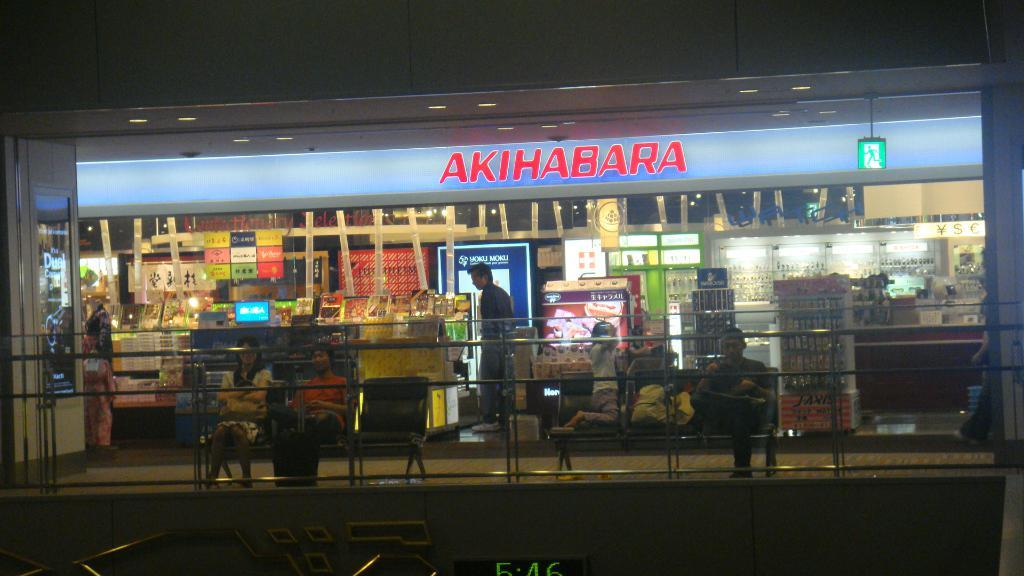<image>
Write a terse but informative summary of the picture. People in front of a store with the name Akihabara. 